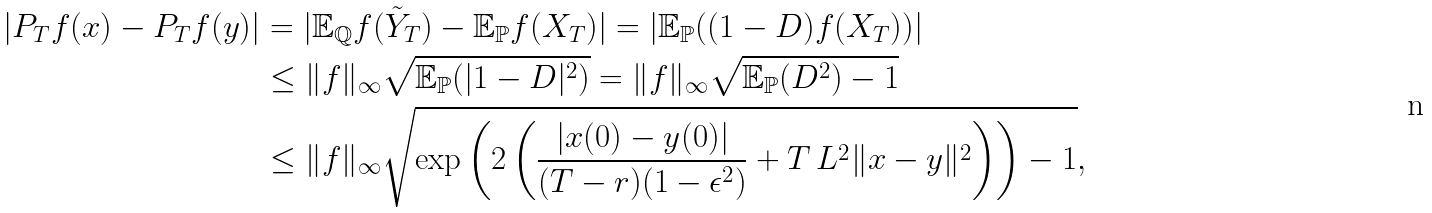Convert formula to latex. <formula><loc_0><loc_0><loc_500><loc_500>| P _ { T } f ( x ) - P _ { T } f ( y ) | & = | \mathbb { E } _ { \mathbb { Q } } f ( \tilde { Y } _ { T } ) - \mathbb { E } _ { \mathbb { P } } f ( X _ { T } ) | = | \mathbb { E } _ { \mathbb { P } } ( ( 1 - D ) f ( X _ { T } ) ) | \\ & \leq \| f \| _ { \infty } \sqrt { \mathbb { E } _ { \mathbb { P } } ( | 1 - D | ^ { 2 } ) } = \| f \| _ { \infty } \sqrt { \mathbb { E } _ { \mathbb { P } } ( D ^ { 2 } ) - 1 } \\ & \leq \| f \| _ { \infty } \sqrt { \exp \left ( 2 \left ( \frac { | x ( 0 ) - y ( 0 ) | } { ( T - r ) ( 1 - \epsilon ^ { 2 } ) } + T \, L ^ { 2 } \| x - y \| ^ { 2 } \right ) \right ) - 1 } ,</formula> 